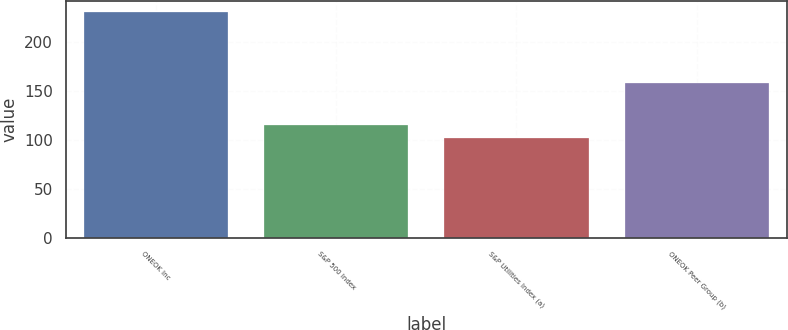<chart> <loc_0><loc_0><loc_500><loc_500><bar_chart><fcel>ONEOK Inc<fcel>S&P 500 Index<fcel>S&P Utilities Index (a)<fcel>ONEOK Peer Group (b)<nl><fcel>230.58<fcel>114.7<fcel>101.83<fcel>158.02<nl></chart> 